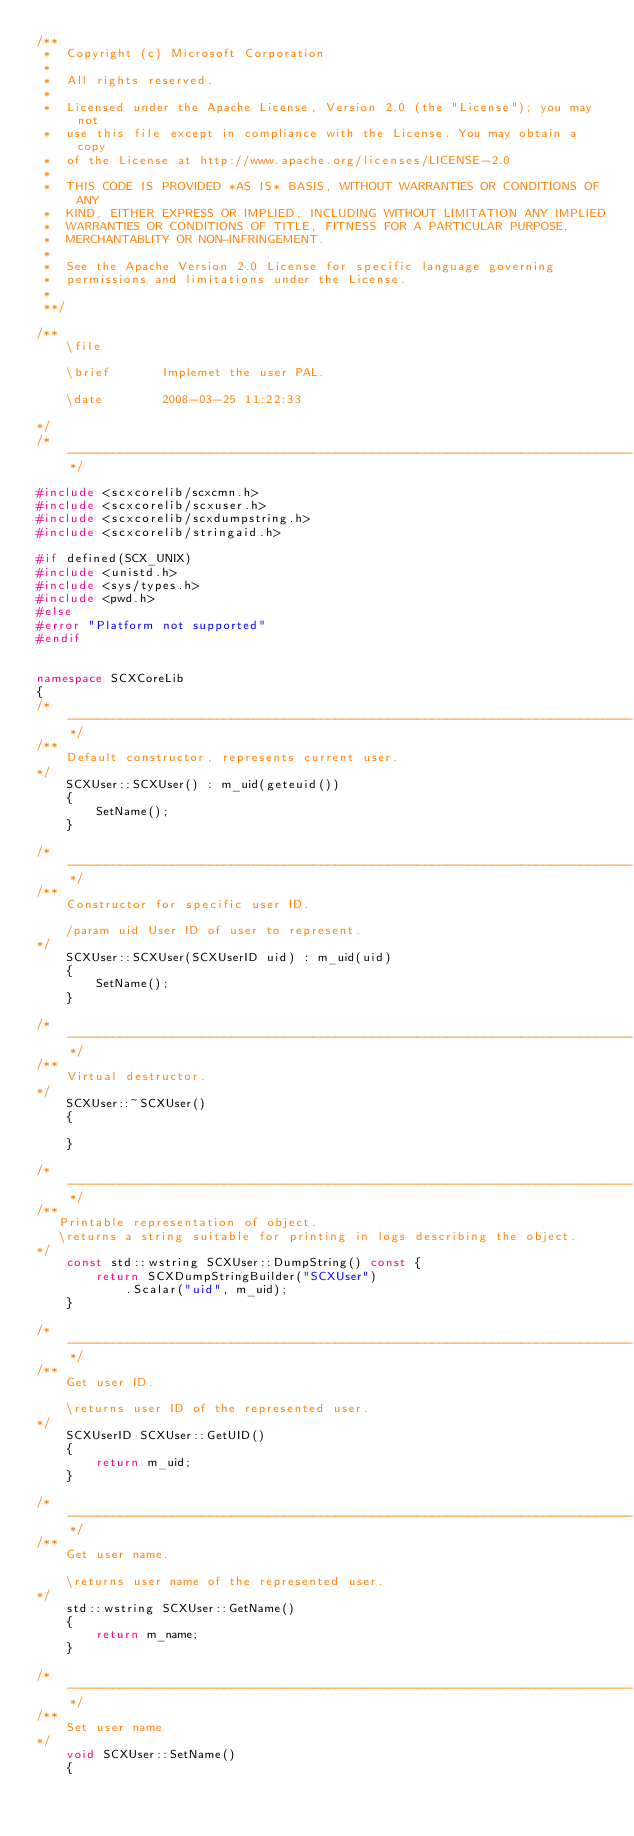<code> <loc_0><loc_0><loc_500><loc_500><_C++_>/**
 *  Copyright (c) Microsoft Corporation
 *
 *  All rights reserved.
 *
 *  Licensed under the Apache License, Version 2.0 (the "License"); you may not
 *  use this file except in compliance with the License. You may obtain a copy
 *  of the License at http://www.apache.org/licenses/LICENSE-2.0
 *
 *  THIS CODE IS PROVIDED *AS IS* BASIS, WITHOUT WARRANTIES OR CONDITIONS OF ANY
 *  KIND, EITHER EXPRESS OR IMPLIED, INCLUDING WITHOUT LIMITATION ANY IMPLIED
 *  WARRANTIES OR CONDITIONS OF TITLE, FITNESS FOR A PARTICULAR PURPOSE,
 *  MERCHANTABLITY OR NON-INFRINGEMENT.
 *
 *  See the Apache Version 2.0 License for specific language governing
 *  permissions and limitations under the License.
 *
 **/

/**
    \file        

    \brief       Implemet the user PAL.
    
    \date        2008-03-25 11:22:33
    
*/
/*----------------------------------------------------------------------------*/

#include <scxcorelib/scxcmn.h>
#include <scxcorelib/scxuser.h>
#include <scxcorelib/scxdumpstring.h>
#include <scxcorelib/stringaid.h>

#if defined(SCX_UNIX)
#include <unistd.h>
#include <sys/types.h>
#include <pwd.h>
#else
#error "Platform not supported"
#endif


namespace SCXCoreLib
{
/*----------------------------------------------------------------------------*/
/**
    Default constructor, represents current user.
*/
    SCXUser::SCXUser() : m_uid(geteuid())
    {
        SetName();
    }

/*----------------------------------------------------------------------------*/
/**
    Constructor for specific user ID.

    /param uid User ID of user to represent.
*/
    SCXUser::SCXUser(SCXUserID uid) : m_uid(uid)
    {
        SetName();
    }
    
/*----------------------------------------------------------------------------*/
/**
    Virtual destructor.
*/
    SCXUser::~SCXUser()
    {

    }

/*----------------------------------------------------------------------------*/
/**
   Printable representation of object.
   \returns a string suitable for printing in logs describing the object.
*/
    const std::wstring SCXUser::DumpString() const {
        return SCXDumpStringBuilder("SCXUser")
            .Scalar("uid", m_uid);
    }

/*----------------------------------------------------------------------------*/
/**
    Get user ID.

    \returns user ID of the represented user.
*/
    SCXUserID SCXUser::GetUID()
    {
        return m_uid;
    }

/*----------------------------------------------------------------------------*/
/**
    Get user name.

    \returns user name of the represented user.
*/
    std::wstring SCXUser::GetName()
    {
        return m_name;
    }

/*----------------------------------------------------------------------------*/
/**
    Set user name
*/
    void SCXUser::SetName()
    {</code> 